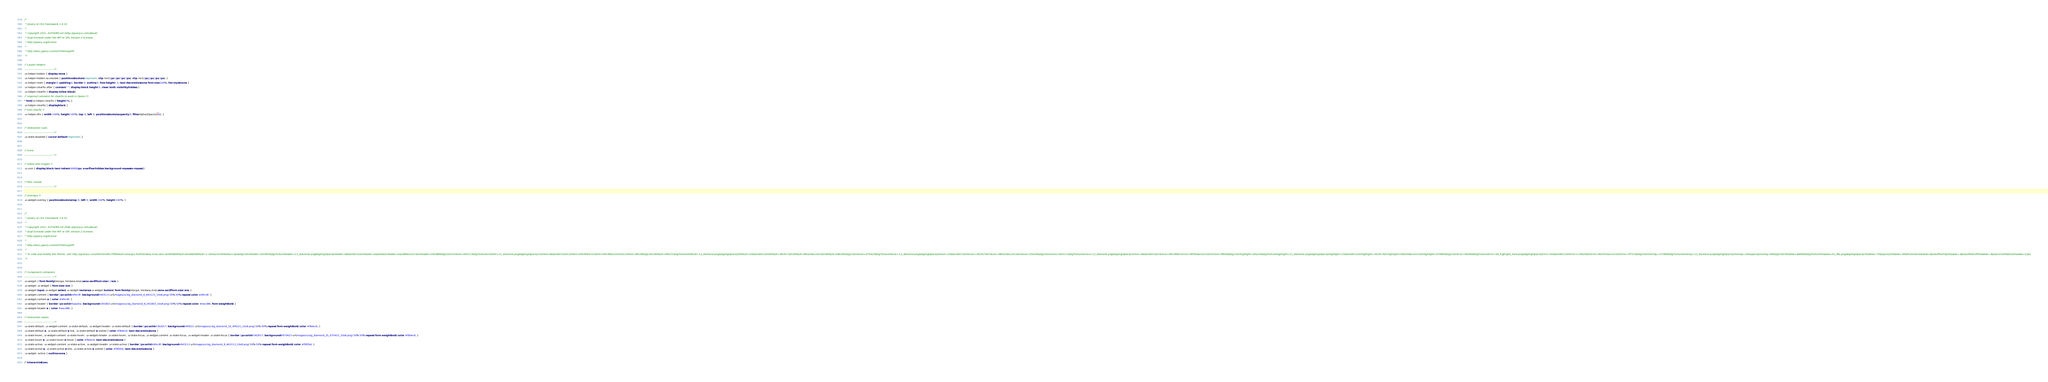Convert code to text. <code><loc_0><loc_0><loc_500><loc_500><_CSS_>/*
 * jQuery UI CSS Framework 1.8.10
 *
 * Copyright 2011, AUTHORS.txt (http://jqueryui.com/about)
 * Dual licensed under the MIT or GPL Version 2 licenses.
 * http://jquery.org/license
 *
 * http://docs.jquery.com/UI/Theming/API
 */

/* Layout helpers
----------------------------------*/
.ui-helper-hidden { display: none; }
.ui-helper-hidden-accessible { position: absolute !important; clip: rect(1px 1px 1px 1px); clip: rect(1px,1px,1px,1px); }
.ui-helper-reset { margin: 0; padding: 0; border: 0; outline: 0; line-height: 1.3; text-decoration: none; font-size: 100%; list-style: none; }
.ui-helper-clearfix:after { content: "."; display: block; height: 0; clear: both; visibility: hidden; }
.ui-helper-clearfix { display: inline-block; }
/* required comment for clearfix to work in Opera \*/
* html .ui-helper-clearfix { height:1%; }
.ui-helper-clearfix { display:block; }
/* end clearfix */
.ui-helper-zfix { width: 100%; height: 100%; top: 0; left: 0; position: absolute; opacity: 0; filter:Alpha(Opacity=0); }


/* Interaction Cues
----------------------------------*/
.ui-state-disabled { cursor: default !important; }


/* Icons
----------------------------------*/

/* states and images */
.ui-icon { display: block; text-indent: -99999px; overflow: hidden; background-repeat: no-repeat; }


/* Misc visuals
----------------------------------*/

/* Overlays */
.ui-widget-overlay { position: absolute; top: 0; left: 0; width: 100%; height: 100%; }


/*
 * jQuery UI CSS Framework 1.8.10
 *
 * Copyright 2011, AUTHORS.txt (http://jqueryui.com/about)
 * Dual licensed under the MIT or GPL Version 2 licenses.
 * http://jquery.org/license
 *
 * http://docs.jquery.com/UI/Theming/API
 *
 * To view and modify this theme, visit http://jqueryui.com/themeroller/?ffDefault=Georgia,%20Verdana,Arial,sans-serif&fwDefault=bold&fsDefault=1.2em&cornerRadius=5px&bgColorHeader=261803&bgTextureHeader=13_diamond.png&bgImgOpacityHeader=8&borderColorHeader=baaa5a&fcHeader=eacd86&iconColorHeader=e9cd86&bgColorContent=443113&bgTextureContent=13_diamond.png&bgImgOpacityContent=8&borderColorContent=efec9f&fcContent=efec9f&iconColorContent=efec9f&bgColorDefault=4f4221&bgTextureDefault=13_diamond.png&bgImgOpacityDefault=10&borderColorDefault=362917&fcDefault=f8eec9&iconColorDefault=e8e2b5&bgColorHover=675423&bgTextureHover=13_diamond.png&bgImgOpacityHover=25&borderColorHover=362917&fcHover=f8eec9&iconColorHover=f2ec64&bgColorActive=443113&bgTextureActive=13_diamond.png&bgImgOpacityActive=8&borderColorActive=efec9f&fcActive=f9f2bd&iconColorActive=f9f2bd&bgColorHighlight=d5ac5d&bgTextureHighlight=13_diamond.png&bgImgOpacityHighlight=25&borderColorHighlight=362917&fcHighlight=060200&iconColorHighlight=070603&bgColorError=fee4bd&bgTextureError=04_highlight_hard.png&bgImgOpacityError=65&borderColorError=c26629&fcError=803f1e&iconColorError=ff7519&bgColorOverlay=372806&bgTextureOverlay=13_diamond.png&bgImgOpacityOverlay=20&opacityOverlay=80&bgColorShadow=ddd4b0&bgTextureShadow=01_flat.png&bgImgOpacityShadow=75&opacityShadow=30&thicknessShadow=8px&offsetTopShadow=-8px&offsetLeftShadow=-8px&cornerRadiusShadow=12px
 */


/* Component containers
----------------------------------*/
.ui-widget { font-family: Georgia, Verdana,Arial,sans-serif; font-size: 1.2em; }
.ui-widget .ui-widget { font-size: 1em; }
.ui-widget input, .ui-widget select, .ui-widget textarea, .ui-widget button { font-family: Georgia, Verdana,Arial,sans-serif; font-size: 1em; }
.ui-widget-content { border: 1px solid #efec9f; background: #443113 url(images/ui-bg_diamond_8_443113_10x8.png) 50% 50% repeat; color: #efec9f; }
.ui-widget-content a { color: #efec9f; }
.ui-widget-header { border: 1px solid #baaa5a; background: #261803 url(images/ui-bg_diamond_8_261803_10x8.png) 50% 50% repeat; color: #eacd86; font-weight: bold; }
.ui-widget-header a { color: #eacd86; }

/* Interaction states
----------------------------------*/
.ui-state-default, .ui-widget-content .ui-state-default, .ui-widget-header .ui-state-default { border: 1px solid #362917; background: #4f4221 url(images/ui-bg_diamond_10_4f4221_10x8.png) 50% 50% repeat; font-weight: bold; color: #f8eec9; }
.ui-state-default a, .ui-state-default a:link, .ui-state-default a:visited { color: #f8eec9; text-decoration: none; }
.ui-state-hover, .ui-widget-content .ui-state-hover, .ui-widget-header .ui-state-hover, .ui-state-focus, .ui-widget-content .ui-state-focus, .ui-widget-header .ui-state-focus { border: 1px solid #362917; background: #675423 url(images/ui-bg_diamond_25_675423_10x8.png) 50% 50% repeat; font-weight: bold; color: #f8eec9; }
.ui-state-hover a, .ui-state-hover a:hover { color: #f8eec9; text-decoration: none; }
.ui-state-active, .ui-widget-content .ui-state-active, .ui-widget-header .ui-state-active { border: 1px solid #efec9f; background: #443113 url(images/ui-bg_diamond_8_443113_10x8.png) 50% 50% repeat; font-weight: bold; color: #f9f2bd; }
.ui-state-active a, .ui-state-active a:link, .ui-state-active a:visited { color: #f9f2bd; text-decoration: none; }
.ui-widget :active { outline: none; }

/* Interaction Cues</code> 